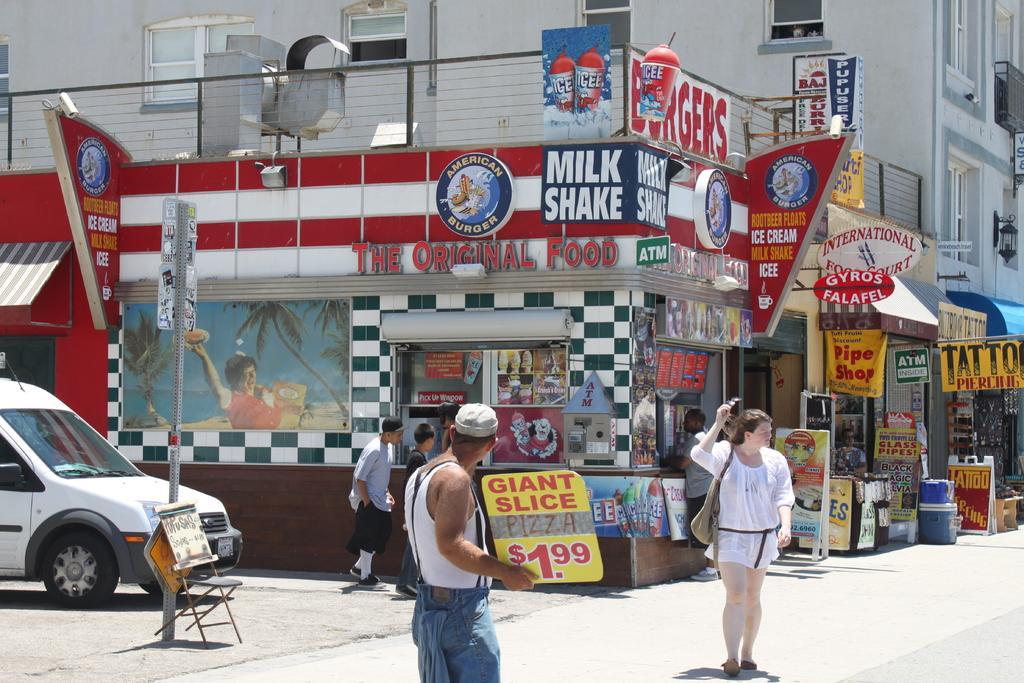Could you give a brief overview of what you see in this image? There are few people standing. These are the name boards attached to the building. I think this is the food court. I can see a van. This looks like a chair, which is kept near the pole. This is the building with windows. I can see baskets and boards are placed on the road. 